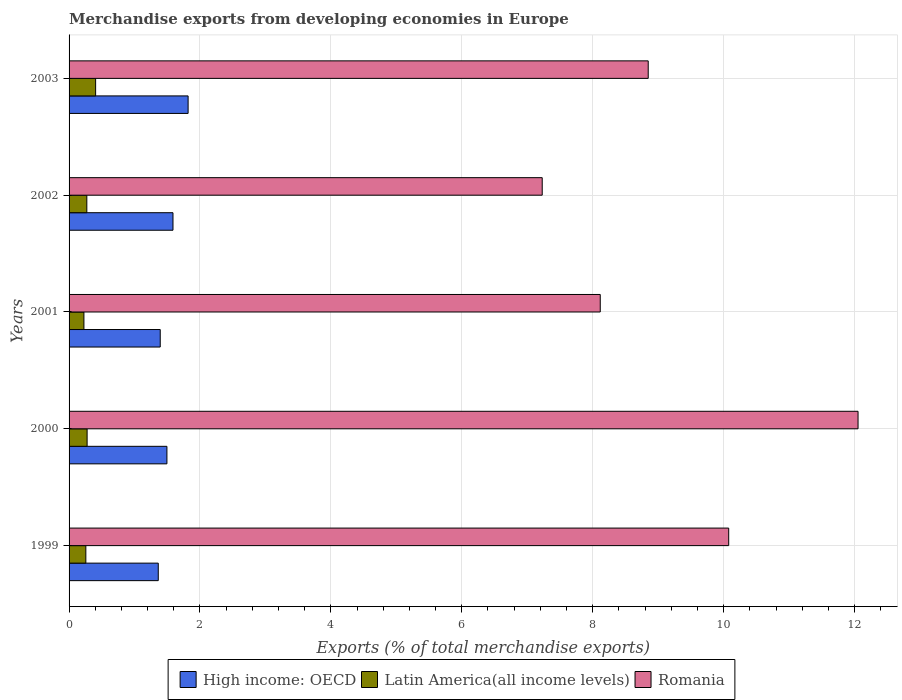How many different coloured bars are there?
Your response must be concise. 3. Are the number of bars per tick equal to the number of legend labels?
Ensure brevity in your answer.  Yes. Are the number of bars on each tick of the Y-axis equal?
Offer a very short reply. Yes. What is the label of the 4th group of bars from the top?
Provide a short and direct response. 2000. In how many cases, is the number of bars for a given year not equal to the number of legend labels?
Offer a terse response. 0. What is the percentage of total merchandise exports in Romania in 1999?
Offer a terse response. 10.08. Across all years, what is the maximum percentage of total merchandise exports in Romania?
Provide a short and direct response. 12.05. Across all years, what is the minimum percentage of total merchandise exports in High income: OECD?
Your answer should be very brief. 1.36. In which year was the percentage of total merchandise exports in High income: OECD maximum?
Provide a short and direct response. 2003. In which year was the percentage of total merchandise exports in High income: OECD minimum?
Make the answer very short. 1999. What is the total percentage of total merchandise exports in Romania in the graph?
Provide a succinct answer. 46.32. What is the difference between the percentage of total merchandise exports in Latin America(all income levels) in 1999 and that in 2003?
Provide a short and direct response. -0.15. What is the difference between the percentage of total merchandise exports in High income: OECD in 2000 and the percentage of total merchandise exports in Latin America(all income levels) in 2002?
Make the answer very short. 1.22. What is the average percentage of total merchandise exports in Romania per year?
Ensure brevity in your answer.  9.26. In the year 1999, what is the difference between the percentage of total merchandise exports in Latin America(all income levels) and percentage of total merchandise exports in High income: OECD?
Keep it short and to the point. -1.11. What is the ratio of the percentage of total merchandise exports in Romania in 1999 to that in 2003?
Keep it short and to the point. 1.14. Is the difference between the percentage of total merchandise exports in Latin America(all income levels) in 2001 and 2002 greater than the difference between the percentage of total merchandise exports in High income: OECD in 2001 and 2002?
Provide a succinct answer. Yes. What is the difference between the highest and the second highest percentage of total merchandise exports in Romania?
Give a very brief answer. 1.98. What is the difference between the highest and the lowest percentage of total merchandise exports in High income: OECD?
Your answer should be very brief. 0.46. What does the 3rd bar from the top in 2002 represents?
Your response must be concise. High income: OECD. What does the 2nd bar from the bottom in 2001 represents?
Keep it short and to the point. Latin America(all income levels). How many bars are there?
Ensure brevity in your answer.  15. How many years are there in the graph?
Offer a very short reply. 5. What is the difference between two consecutive major ticks on the X-axis?
Your response must be concise. 2. Are the values on the major ticks of X-axis written in scientific E-notation?
Ensure brevity in your answer.  No. Does the graph contain grids?
Your answer should be very brief. Yes. Where does the legend appear in the graph?
Offer a very short reply. Bottom center. How many legend labels are there?
Your response must be concise. 3. How are the legend labels stacked?
Offer a very short reply. Horizontal. What is the title of the graph?
Offer a terse response. Merchandise exports from developing economies in Europe. What is the label or title of the X-axis?
Keep it short and to the point. Exports (% of total merchandise exports). What is the Exports (% of total merchandise exports) in High income: OECD in 1999?
Your answer should be compact. 1.36. What is the Exports (% of total merchandise exports) of Latin America(all income levels) in 1999?
Make the answer very short. 0.26. What is the Exports (% of total merchandise exports) of Romania in 1999?
Give a very brief answer. 10.08. What is the Exports (% of total merchandise exports) in High income: OECD in 2000?
Your answer should be very brief. 1.49. What is the Exports (% of total merchandise exports) in Latin America(all income levels) in 2000?
Keep it short and to the point. 0.28. What is the Exports (% of total merchandise exports) of Romania in 2000?
Keep it short and to the point. 12.05. What is the Exports (% of total merchandise exports) of High income: OECD in 2001?
Make the answer very short. 1.39. What is the Exports (% of total merchandise exports) in Latin America(all income levels) in 2001?
Offer a very short reply. 0.23. What is the Exports (% of total merchandise exports) of Romania in 2001?
Give a very brief answer. 8.11. What is the Exports (% of total merchandise exports) in High income: OECD in 2002?
Provide a succinct answer. 1.59. What is the Exports (% of total merchandise exports) in Latin America(all income levels) in 2002?
Make the answer very short. 0.27. What is the Exports (% of total merchandise exports) of Romania in 2002?
Provide a short and direct response. 7.23. What is the Exports (% of total merchandise exports) in High income: OECD in 2003?
Your response must be concise. 1.82. What is the Exports (% of total merchandise exports) of Latin America(all income levels) in 2003?
Provide a short and direct response. 0.41. What is the Exports (% of total merchandise exports) in Romania in 2003?
Give a very brief answer. 8.85. Across all years, what is the maximum Exports (% of total merchandise exports) in High income: OECD?
Make the answer very short. 1.82. Across all years, what is the maximum Exports (% of total merchandise exports) in Latin America(all income levels)?
Ensure brevity in your answer.  0.41. Across all years, what is the maximum Exports (% of total merchandise exports) in Romania?
Your answer should be compact. 12.05. Across all years, what is the minimum Exports (% of total merchandise exports) of High income: OECD?
Your answer should be very brief. 1.36. Across all years, what is the minimum Exports (% of total merchandise exports) of Latin America(all income levels)?
Offer a terse response. 0.23. Across all years, what is the minimum Exports (% of total merchandise exports) of Romania?
Provide a succinct answer. 7.23. What is the total Exports (% of total merchandise exports) in High income: OECD in the graph?
Your answer should be compact. 7.66. What is the total Exports (% of total merchandise exports) in Latin America(all income levels) in the graph?
Ensure brevity in your answer.  1.44. What is the total Exports (% of total merchandise exports) in Romania in the graph?
Keep it short and to the point. 46.32. What is the difference between the Exports (% of total merchandise exports) of High income: OECD in 1999 and that in 2000?
Make the answer very short. -0.13. What is the difference between the Exports (% of total merchandise exports) in Latin America(all income levels) in 1999 and that in 2000?
Provide a short and direct response. -0.02. What is the difference between the Exports (% of total merchandise exports) in Romania in 1999 and that in 2000?
Make the answer very short. -1.98. What is the difference between the Exports (% of total merchandise exports) in High income: OECD in 1999 and that in 2001?
Give a very brief answer. -0.03. What is the difference between the Exports (% of total merchandise exports) in Latin America(all income levels) in 1999 and that in 2001?
Your answer should be very brief. 0.03. What is the difference between the Exports (% of total merchandise exports) in Romania in 1999 and that in 2001?
Give a very brief answer. 1.96. What is the difference between the Exports (% of total merchandise exports) of High income: OECD in 1999 and that in 2002?
Your answer should be compact. -0.23. What is the difference between the Exports (% of total merchandise exports) in Latin America(all income levels) in 1999 and that in 2002?
Offer a terse response. -0.02. What is the difference between the Exports (% of total merchandise exports) in Romania in 1999 and that in 2002?
Your response must be concise. 2.85. What is the difference between the Exports (% of total merchandise exports) in High income: OECD in 1999 and that in 2003?
Your answer should be compact. -0.46. What is the difference between the Exports (% of total merchandise exports) of Latin America(all income levels) in 1999 and that in 2003?
Your response must be concise. -0.15. What is the difference between the Exports (% of total merchandise exports) of Romania in 1999 and that in 2003?
Make the answer very short. 1.23. What is the difference between the Exports (% of total merchandise exports) in High income: OECD in 2000 and that in 2001?
Give a very brief answer. 0.1. What is the difference between the Exports (% of total merchandise exports) of Latin America(all income levels) in 2000 and that in 2001?
Provide a succinct answer. 0.05. What is the difference between the Exports (% of total merchandise exports) in Romania in 2000 and that in 2001?
Offer a very short reply. 3.94. What is the difference between the Exports (% of total merchandise exports) in High income: OECD in 2000 and that in 2002?
Your response must be concise. -0.09. What is the difference between the Exports (% of total merchandise exports) in Latin America(all income levels) in 2000 and that in 2002?
Make the answer very short. 0. What is the difference between the Exports (% of total merchandise exports) of Romania in 2000 and that in 2002?
Provide a succinct answer. 4.82. What is the difference between the Exports (% of total merchandise exports) of High income: OECD in 2000 and that in 2003?
Offer a terse response. -0.32. What is the difference between the Exports (% of total merchandise exports) of Latin America(all income levels) in 2000 and that in 2003?
Provide a succinct answer. -0.13. What is the difference between the Exports (% of total merchandise exports) of Romania in 2000 and that in 2003?
Your answer should be compact. 3.21. What is the difference between the Exports (% of total merchandise exports) of High income: OECD in 2001 and that in 2002?
Your answer should be very brief. -0.19. What is the difference between the Exports (% of total merchandise exports) of Latin America(all income levels) in 2001 and that in 2002?
Offer a very short reply. -0.04. What is the difference between the Exports (% of total merchandise exports) in Romania in 2001 and that in 2002?
Make the answer very short. 0.89. What is the difference between the Exports (% of total merchandise exports) in High income: OECD in 2001 and that in 2003?
Offer a terse response. -0.43. What is the difference between the Exports (% of total merchandise exports) in Latin America(all income levels) in 2001 and that in 2003?
Provide a succinct answer. -0.18. What is the difference between the Exports (% of total merchandise exports) in Romania in 2001 and that in 2003?
Make the answer very short. -0.73. What is the difference between the Exports (% of total merchandise exports) in High income: OECD in 2002 and that in 2003?
Make the answer very short. -0.23. What is the difference between the Exports (% of total merchandise exports) in Latin America(all income levels) in 2002 and that in 2003?
Give a very brief answer. -0.13. What is the difference between the Exports (% of total merchandise exports) in Romania in 2002 and that in 2003?
Ensure brevity in your answer.  -1.62. What is the difference between the Exports (% of total merchandise exports) of High income: OECD in 1999 and the Exports (% of total merchandise exports) of Latin America(all income levels) in 2000?
Make the answer very short. 1.09. What is the difference between the Exports (% of total merchandise exports) of High income: OECD in 1999 and the Exports (% of total merchandise exports) of Romania in 2000?
Your answer should be compact. -10.69. What is the difference between the Exports (% of total merchandise exports) of Latin America(all income levels) in 1999 and the Exports (% of total merchandise exports) of Romania in 2000?
Offer a terse response. -11.8. What is the difference between the Exports (% of total merchandise exports) in High income: OECD in 1999 and the Exports (% of total merchandise exports) in Latin America(all income levels) in 2001?
Keep it short and to the point. 1.14. What is the difference between the Exports (% of total merchandise exports) of High income: OECD in 1999 and the Exports (% of total merchandise exports) of Romania in 2001?
Ensure brevity in your answer.  -6.75. What is the difference between the Exports (% of total merchandise exports) of Latin America(all income levels) in 1999 and the Exports (% of total merchandise exports) of Romania in 2001?
Your answer should be compact. -7.86. What is the difference between the Exports (% of total merchandise exports) of High income: OECD in 1999 and the Exports (% of total merchandise exports) of Latin America(all income levels) in 2002?
Your answer should be very brief. 1.09. What is the difference between the Exports (% of total merchandise exports) of High income: OECD in 1999 and the Exports (% of total merchandise exports) of Romania in 2002?
Your answer should be very brief. -5.87. What is the difference between the Exports (% of total merchandise exports) of Latin America(all income levels) in 1999 and the Exports (% of total merchandise exports) of Romania in 2002?
Make the answer very short. -6.97. What is the difference between the Exports (% of total merchandise exports) in High income: OECD in 1999 and the Exports (% of total merchandise exports) in Latin America(all income levels) in 2003?
Provide a short and direct response. 0.96. What is the difference between the Exports (% of total merchandise exports) of High income: OECD in 1999 and the Exports (% of total merchandise exports) of Romania in 2003?
Your answer should be very brief. -7.49. What is the difference between the Exports (% of total merchandise exports) of Latin America(all income levels) in 1999 and the Exports (% of total merchandise exports) of Romania in 2003?
Offer a very short reply. -8.59. What is the difference between the Exports (% of total merchandise exports) of High income: OECD in 2000 and the Exports (% of total merchandise exports) of Latin America(all income levels) in 2001?
Offer a terse response. 1.27. What is the difference between the Exports (% of total merchandise exports) of High income: OECD in 2000 and the Exports (% of total merchandise exports) of Romania in 2001?
Offer a terse response. -6.62. What is the difference between the Exports (% of total merchandise exports) in Latin America(all income levels) in 2000 and the Exports (% of total merchandise exports) in Romania in 2001?
Keep it short and to the point. -7.84. What is the difference between the Exports (% of total merchandise exports) of High income: OECD in 2000 and the Exports (% of total merchandise exports) of Latin America(all income levels) in 2002?
Give a very brief answer. 1.22. What is the difference between the Exports (% of total merchandise exports) of High income: OECD in 2000 and the Exports (% of total merchandise exports) of Romania in 2002?
Ensure brevity in your answer.  -5.73. What is the difference between the Exports (% of total merchandise exports) in Latin America(all income levels) in 2000 and the Exports (% of total merchandise exports) in Romania in 2002?
Your answer should be very brief. -6.95. What is the difference between the Exports (% of total merchandise exports) of High income: OECD in 2000 and the Exports (% of total merchandise exports) of Latin America(all income levels) in 2003?
Your answer should be compact. 1.09. What is the difference between the Exports (% of total merchandise exports) in High income: OECD in 2000 and the Exports (% of total merchandise exports) in Romania in 2003?
Provide a short and direct response. -7.35. What is the difference between the Exports (% of total merchandise exports) in Latin America(all income levels) in 2000 and the Exports (% of total merchandise exports) in Romania in 2003?
Your answer should be compact. -8.57. What is the difference between the Exports (% of total merchandise exports) of High income: OECD in 2001 and the Exports (% of total merchandise exports) of Latin America(all income levels) in 2002?
Keep it short and to the point. 1.12. What is the difference between the Exports (% of total merchandise exports) in High income: OECD in 2001 and the Exports (% of total merchandise exports) in Romania in 2002?
Keep it short and to the point. -5.84. What is the difference between the Exports (% of total merchandise exports) in Latin America(all income levels) in 2001 and the Exports (% of total merchandise exports) in Romania in 2002?
Keep it short and to the point. -7. What is the difference between the Exports (% of total merchandise exports) in High income: OECD in 2001 and the Exports (% of total merchandise exports) in Latin America(all income levels) in 2003?
Your answer should be compact. 0.99. What is the difference between the Exports (% of total merchandise exports) in High income: OECD in 2001 and the Exports (% of total merchandise exports) in Romania in 2003?
Your answer should be compact. -7.46. What is the difference between the Exports (% of total merchandise exports) of Latin America(all income levels) in 2001 and the Exports (% of total merchandise exports) of Romania in 2003?
Your response must be concise. -8.62. What is the difference between the Exports (% of total merchandise exports) in High income: OECD in 2002 and the Exports (% of total merchandise exports) in Latin America(all income levels) in 2003?
Make the answer very short. 1.18. What is the difference between the Exports (% of total merchandise exports) in High income: OECD in 2002 and the Exports (% of total merchandise exports) in Romania in 2003?
Ensure brevity in your answer.  -7.26. What is the difference between the Exports (% of total merchandise exports) in Latin America(all income levels) in 2002 and the Exports (% of total merchandise exports) in Romania in 2003?
Your response must be concise. -8.58. What is the average Exports (% of total merchandise exports) of High income: OECD per year?
Offer a terse response. 1.53. What is the average Exports (% of total merchandise exports) of Latin America(all income levels) per year?
Your response must be concise. 0.29. What is the average Exports (% of total merchandise exports) of Romania per year?
Offer a terse response. 9.26. In the year 1999, what is the difference between the Exports (% of total merchandise exports) in High income: OECD and Exports (% of total merchandise exports) in Latin America(all income levels)?
Keep it short and to the point. 1.11. In the year 1999, what is the difference between the Exports (% of total merchandise exports) of High income: OECD and Exports (% of total merchandise exports) of Romania?
Keep it short and to the point. -8.71. In the year 1999, what is the difference between the Exports (% of total merchandise exports) in Latin America(all income levels) and Exports (% of total merchandise exports) in Romania?
Ensure brevity in your answer.  -9.82. In the year 2000, what is the difference between the Exports (% of total merchandise exports) of High income: OECD and Exports (% of total merchandise exports) of Latin America(all income levels)?
Your answer should be very brief. 1.22. In the year 2000, what is the difference between the Exports (% of total merchandise exports) of High income: OECD and Exports (% of total merchandise exports) of Romania?
Ensure brevity in your answer.  -10.56. In the year 2000, what is the difference between the Exports (% of total merchandise exports) in Latin America(all income levels) and Exports (% of total merchandise exports) in Romania?
Provide a succinct answer. -11.78. In the year 2001, what is the difference between the Exports (% of total merchandise exports) of High income: OECD and Exports (% of total merchandise exports) of Latin America(all income levels)?
Keep it short and to the point. 1.17. In the year 2001, what is the difference between the Exports (% of total merchandise exports) of High income: OECD and Exports (% of total merchandise exports) of Romania?
Keep it short and to the point. -6.72. In the year 2001, what is the difference between the Exports (% of total merchandise exports) in Latin America(all income levels) and Exports (% of total merchandise exports) in Romania?
Give a very brief answer. -7.89. In the year 2002, what is the difference between the Exports (% of total merchandise exports) of High income: OECD and Exports (% of total merchandise exports) of Latin America(all income levels)?
Your answer should be very brief. 1.32. In the year 2002, what is the difference between the Exports (% of total merchandise exports) in High income: OECD and Exports (% of total merchandise exports) in Romania?
Provide a succinct answer. -5.64. In the year 2002, what is the difference between the Exports (% of total merchandise exports) in Latin America(all income levels) and Exports (% of total merchandise exports) in Romania?
Offer a very short reply. -6.96. In the year 2003, what is the difference between the Exports (% of total merchandise exports) in High income: OECD and Exports (% of total merchandise exports) in Latin America(all income levels)?
Keep it short and to the point. 1.41. In the year 2003, what is the difference between the Exports (% of total merchandise exports) in High income: OECD and Exports (% of total merchandise exports) in Romania?
Make the answer very short. -7.03. In the year 2003, what is the difference between the Exports (% of total merchandise exports) of Latin America(all income levels) and Exports (% of total merchandise exports) of Romania?
Ensure brevity in your answer.  -8.44. What is the ratio of the Exports (% of total merchandise exports) of High income: OECD in 1999 to that in 2000?
Make the answer very short. 0.91. What is the ratio of the Exports (% of total merchandise exports) of Latin America(all income levels) in 1999 to that in 2000?
Provide a succinct answer. 0.93. What is the ratio of the Exports (% of total merchandise exports) in Romania in 1999 to that in 2000?
Your answer should be very brief. 0.84. What is the ratio of the Exports (% of total merchandise exports) of High income: OECD in 1999 to that in 2001?
Your answer should be very brief. 0.98. What is the ratio of the Exports (% of total merchandise exports) of Latin America(all income levels) in 1999 to that in 2001?
Your answer should be compact. 1.13. What is the ratio of the Exports (% of total merchandise exports) in Romania in 1999 to that in 2001?
Give a very brief answer. 1.24. What is the ratio of the Exports (% of total merchandise exports) in High income: OECD in 1999 to that in 2002?
Your answer should be compact. 0.86. What is the ratio of the Exports (% of total merchandise exports) of Latin America(all income levels) in 1999 to that in 2002?
Give a very brief answer. 0.94. What is the ratio of the Exports (% of total merchandise exports) in Romania in 1999 to that in 2002?
Your answer should be compact. 1.39. What is the ratio of the Exports (% of total merchandise exports) in High income: OECD in 1999 to that in 2003?
Provide a succinct answer. 0.75. What is the ratio of the Exports (% of total merchandise exports) in Latin America(all income levels) in 1999 to that in 2003?
Keep it short and to the point. 0.63. What is the ratio of the Exports (% of total merchandise exports) of Romania in 1999 to that in 2003?
Offer a terse response. 1.14. What is the ratio of the Exports (% of total merchandise exports) in High income: OECD in 2000 to that in 2001?
Provide a short and direct response. 1.07. What is the ratio of the Exports (% of total merchandise exports) of Latin America(all income levels) in 2000 to that in 2001?
Provide a succinct answer. 1.22. What is the ratio of the Exports (% of total merchandise exports) in Romania in 2000 to that in 2001?
Offer a very short reply. 1.49. What is the ratio of the Exports (% of total merchandise exports) of High income: OECD in 2000 to that in 2002?
Offer a terse response. 0.94. What is the ratio of the Exports (% of total merchandise exports) in Latin America(all income levels) in 2000 to that in 2002?
Keep it short and to the point. 1.02. What is the ratio of the Exports (% of total merchandise exports) of Romania in 2000 to that in 2002?
Give a very brief answer. 1.67. What is the ratio of the Exports (% of total merchandise exports) in High income: OECD in 2000 to that in 2003?
Keep it short and to the point. 0.82. What is the ratio of the Exports (% of total merchandise exports) in Latin America(all income levels) in 2000 to that in 2003?
Your answer should be very brief. 0.68. What is the ratio of the Exports (% of total merchandise exports) in Romania in 2000 to that in 2003?
Your response must be concise. 1.36. What is the ratio of the Exports (% of total merchandise exports) in High income: OECD in 2001 to that in 2002?
Offer a terse response. 0.88. What is the ratio of the Exports (% of total merchandise exports) of Latin America(all income levels) in 2001 to that in 2002?
Your answer should be very brief. 0.84. What is the ratio of the Exports (% of total merchandise exports) of Romania in 2001 to that in 2002?
Your answer should be very brief. 1.12. What is the ratio of the Exports (% of total merchandise exports) of High income: OECD in 2001 to that in 2003?
Give a very brief answer. 0.77. What is the ratio of the Exports (% of total merchandise exports) of Latin America(all income levels) in 2001 to that in 2003?
Make the answer very short. 0.56. What is the ratio of the Exports (% of total merchandise exports) in Romania in 2001 to that in 2003?
Offer a terse response. 0.92. What is the ratio of the Exports (% of total merchandise exports) of High income: OECD in 2002 to that in 2003?
Keep it short and to the point. 0.87. What is the ratio of the Exports (% of total merchandise exports) of Latin America(all income levels) in 2002 to that in 2003?
Your answer should be very brief. 0.67. What is the ratio of the Exports (% of total merchandise exports) of Romania in 2002 to that in 2003?
Provide a succinct answer. 0.82. What is the difference between the highest and the second highest Exports (% of total merchandise exports) of High income: OECD?
Ensure brevity in your answer.  0.23. What is the difference between the highest and the second highest Exports (% of total merchandise exports) of Latin America(all income levels)?
Your answer should be very brief. 0.13. What is the difference between the highest and the second highest Exports (% of total merchandise exports) in Romania?
Give a very brief answer. 1.98. What is the difference between the highest and the lowest Exports (% of total merchandise exports) of High income: OECD?
Keep it short and to the point. 0.46. What is the difference between the highest and the lowest Exports (% of total merchandise exports) of Latin America(all income levels)?
Provide a succinct answer. 0.18. What is the difference between the highest and the lowest Exports (% of total merchandise exports) in Romania?
Give a very brief answer. 4.82. 